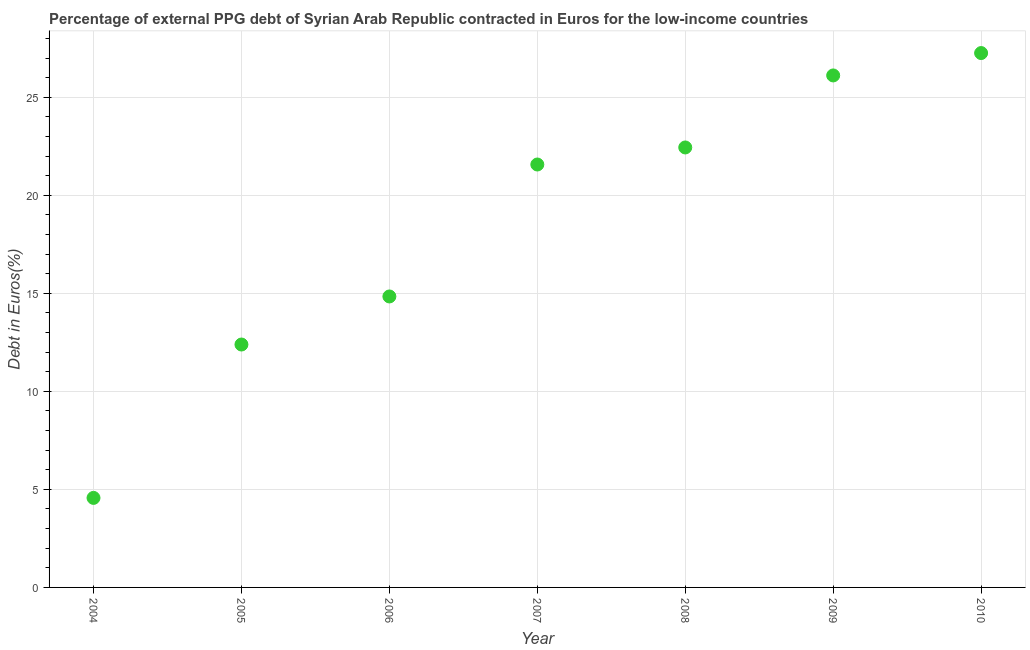What is the currency composition of ppg debt in 2008?
Your answer should be very brief. 22.44. Across all years, what is the maximum currency composition of ppg debt?
Your answer should be compact. 27.25. Across all years, what is the minimum currency composition of ppg debt?
Give a very brief answer. 4.57. In which year was the currency composition of ppg debt minimum?
Give a very brief answer. 2004. What is the sum of the currency composition of ppg debt?
Keep it short and to the point. 129.17. What is the difference between the currency composition of ppg debt in 2004 and 2005?
Offer a terse response. -7.82. What is the average currency composition of ppg debt per year?
Make the answer very short. 18.45. What is the median currency composition of ppg debt?
Give a very brief answer. 21.57. Do a majority of the years between 2009 and 2006 (inclusive) have currency composition of ppg debt greater than 23 %?
Provide a short and direct response. Yes. What is the ratio of the currency composition of ppg debt in 2009 to that in 2010?
Keep it short and to the point. 0.96. Is the currency composition of ppg debt in 2004 less than that in 2008?
Your answer should be very brief. Yes. Is the difference between the currency composition of ppg debt in 2007 and 2008 greater than the difference between any two years?
Provide a succinct answer. No. What is the difference between the highest and the second highest currency composition of ppg debt?
Provide a succinct answer. 1.14. Is the sum of the currency composition of ppg debt in 2006 and 2008 greater than the maximum currency composition of ppg debt across all years?
Keep it short and to the point. Yes. What is the difference between the highest and the lowest currency composition of ppg debt?
Keep it short and to the point. 22.69. In how many years, is the currency composition of ppg debt greater than the average currency composition of ppg debt taken over all years?
Provide a succinct answer. 4. Does the currency composition of ppg debt monotonically increase over the years?
Keep it short and to the point. Yes. How many years are there in the graph?
Your answer should be very brief. 7. Are the values on the major ticks of Y-axis written in scientific E-notation?
Make the answer very short. No. Does the graph contain grids?
Offer a very short reply. Yes. What is the title of the graph?
Make the answer very short. Percentage of external PPG debt of Syrian Arab Republic contracted in Euros for the low-income countries. What is the label or title of the X-axis?
Keep it short and to the point. Year. What is the label or title of the Y-axis?
Keep it short and to the point. Debt in Euros(%). What is the Debt in Euros(%) in 2004?
Offer a terse response. 4.57. What is the Debt in Euros(%) in 2005?
Give a very brief answer. 12.39. What is the Debt in Euros(%) in 2006?
Offer a very short reply. 14.84. What is the Debt in Euros(%) in 2007?
Offer a very short reply. 21.57. What is the Debt in Euros(%) in 2008?
Provide a succinct answer. 22.44. What is the Debt in Euros(%) in 2009?
Keep it short and to the point. 26.11. What is the Debt in Euros(%) in 2010?
Your answer should be compact. 27.25. What is the difference between the Debt in Euros(%) in 2004 and 2005?
Ensure brevity in your answer.  -7.82. What is the difference between the Debt in Euros(%) in 2004 and 2006?
Offer a very short reply. -10.27. What is the difference between the Debt in Euros(%) in 2004 and 2007?
Provide a succinct answer. -17. What is the difference between the Debt in Euros(%) in 2004 and 2008?
Give a very brief answer. -17.87. What is the difference between the Debt in Euros(%) in 2004 and 2009?
Ensure brevity in your answer.  -21.55. What is the difference between the Debt in Euros(%) in 2004 and 2010?
Give a very brief answer. -22.69. What is the difference between the Debt in Euros(%) in 2005 and 2006?
Offer a very short reply. -2.45. What is the difference between the Debt in Euros(%) in 2005 and 2007?
Give a very brief answer. -9.18. What is the difference between the Debt in Euros(%) in 2005 and 2008?
Keep it short and to the point. -10.05. What is the difference between the Debt in Euros(%) in 2005 and 2009?
Provide a short and direct response. -13.72. What is the difference between the Debt in Euros(%) in 2005 and 2010?
Ensure brevity in your answer.  -14.86. What is the difference between the Debt in Euros(%) in 2006 and 2007?
Ensure brevity in your answer.  -6.73. What is the difference between the Debt in Euros(%) in 2006 and 2008?
Offer a very short reply. -7.6. What is the difference between the Debt in Euros(%) in 2006 and 2009?
Your answer should be very brief. -11.27. What is the difference between the Debt in Euros(%) in 2006 and 2010?
Ensure brevity in your answer.  -12.41. What is the difference between the Debt in Euros(%) in 2007 and 2008?
Your response must be concise. -0.87. What is the difference between the Debt in Euros(%) in 2007 and 2009?
Make the answer very short. -4.54. What is the difference between the Debt in Euros(%) in 2007 and 2010?
Offer a very short reply. -5.68. What is the difference between the Debt in Euros(%) in 2008 and 2009?
Give a very brief answer. -3.67. What is the difference between the Debt in Euros(%) in 2008 and 2010?
Provide a succinct answer. -4.81. What is the difference between the Debt in Euros(%) in 2009 and 2010?
Provide a short and direct response. -1.14. What is the ratio of the Debt in Euros(%) in 2004 to that in 2005?
Offer a very short reply. 0.37. What is the ratio of the Debt in Euros(%) in 2004 to that in 2006?
Ensure brevity in your answer.  0.31. What is the ratio of the Debt in Euros(%) in 2004 to that in 2007?
Offer a very short reply. 0.21. What is the ratio of the Debt in Euros(%) in 2004 to that in 2008?
Provide a succinct answer. 0.2. What is the ratio of the Debt in Euros(%) in 2004 to that in 2009?
Your answer should be very brief. 0.17. What is the ratio of the Debt in Euros(%) in 2004 to that in 2010?
Make the answer very short. 0.17. What is the ratio of the Debt in Euros(%) in 2005 to that in 2006?
Offer a terse response. 0.83. What is the ratio of the Debt in Euros(%) in 2005 to that in 2007?
Make the answer very short. 0.57. What is the ratio of the Debt in Euros(%) in 2005 to that in 2008?
Provide a short and direct response. 0.55. What is the ratio of the Debt in Euros(%) in 2005 to that in 2009?
Provide a succinct answer. 0.47. What is the ratio of the Debt in Euros(%) in 2005 to that in 2010?
Offer a very short reply. 0.46. What is the ratio of the Debt in Euros(%) in 2006 to that in 2007?
Your answer should be very brief. 0.69. What is the ratio of the Debt in Euros(%) in 2006 to that in 2008?
Provide a short and direct response. 0.66. What is the ratio of the Debt in Euros(%) in 2006 to that in 2009?
Provide a succinct answer. 0.57. What is the ratio of the Debt in Euros(%) in 2006 to that in 2010?
Provide a succinct answer. 0.55. What is the ratio of the Debt in Euros(%) in 2007 to that in 2009?
Your answer should be compact. 0.83. What is the ratio of the Debt in Euros(%) in 2007 to that in 2010?
Give a very brief answer. 0.79. What is the ratio of the Debt in Euros(%) in 2008 to that in 2009?
Make the answer very short. 0.86. What is the ratio of the Debt in Euros(%) in 2008 to that in 2010?
Ensure brevity in your answer.  0.82. What is the ratio of the Debt in Euros(%) in 2009 to that in 2010?
Your response must be concise. 0.96. 